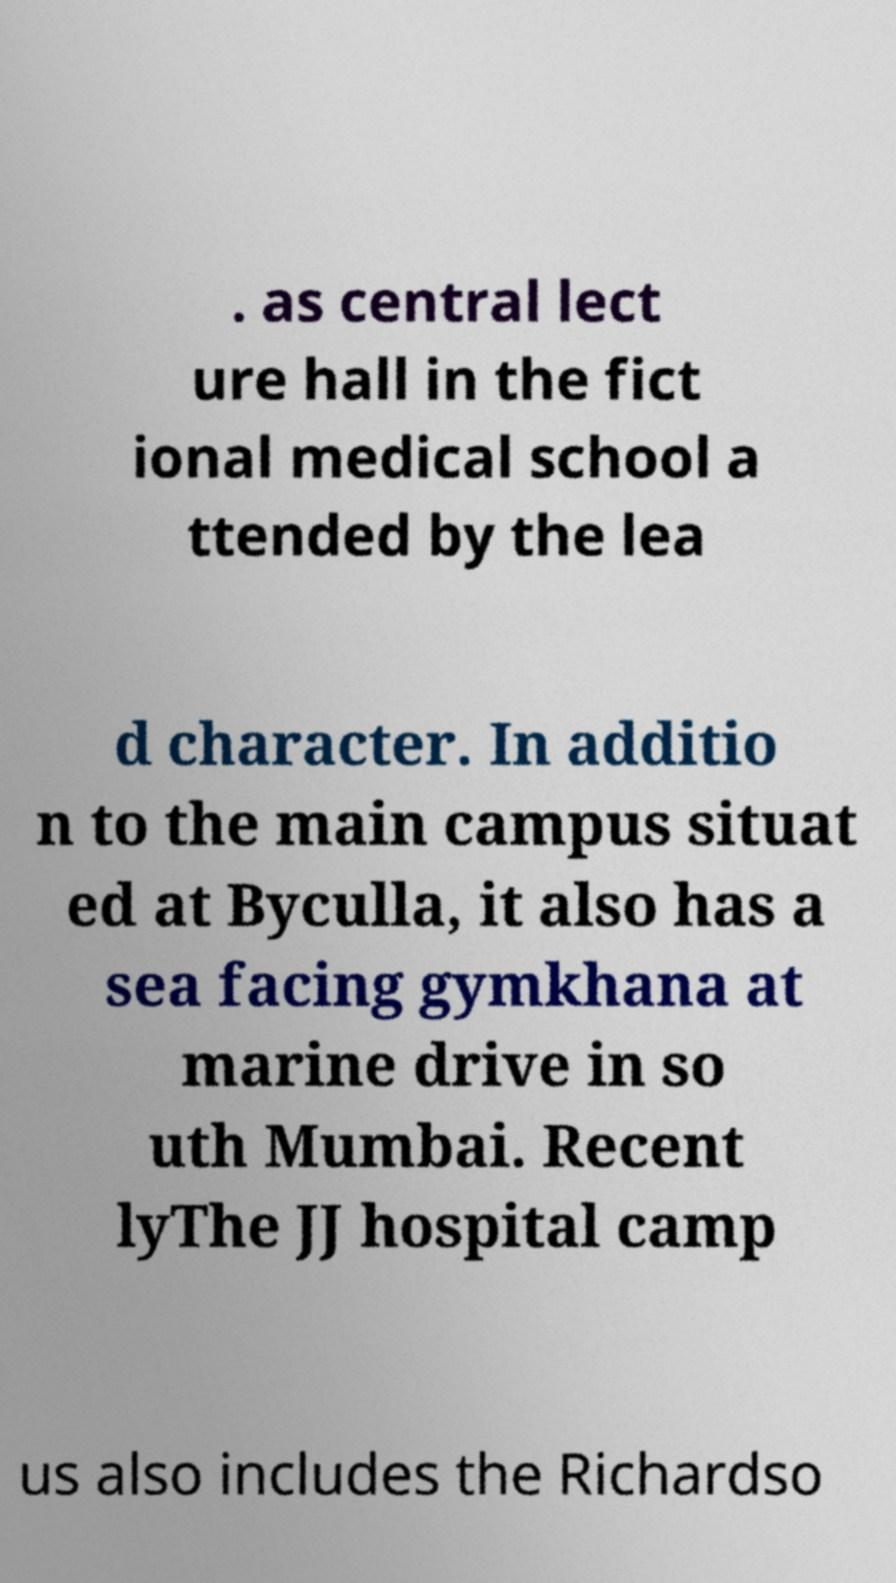Could you assist in decoding the text presented in this image and type it out clearly? . as central lect ure hall in the fict ional medical school a ttended by the lea d character. In additio n to the main campus situat ed at Byculla, it also has a sea facing gymkhana at marine drive in so uth Mumbai. Recent lyThe JJ hospital camp us also includes the Richardso 